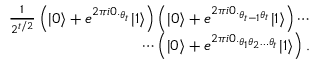Convert formula to latex. <formula><loc_0><loc_0><loc_500><loc_500>\begin{array} { r } { \frac { 1 } { 2 ^ { t / 2 } } \left ( | 0 \rangle + e ^ { 2 \pi i 0 . _ { \theta _ { t } } } | 1 \rangle \right ) \left ( | 0 \rangle + e ^ { 2 \pi i 0 . _ { \theta _ { t - 1 } \theta _ { t } } } | 1 \rangle \right ) \cdots } \\ { \cdots \left ( | 0 \rangle + e ^ { 2 \pi i 0 . _ { \theta _ { 1 } \theta _ { 2 } \dots \theta _ { t } } } | 1 \rangle \right ) . } \end{array}</formula> 